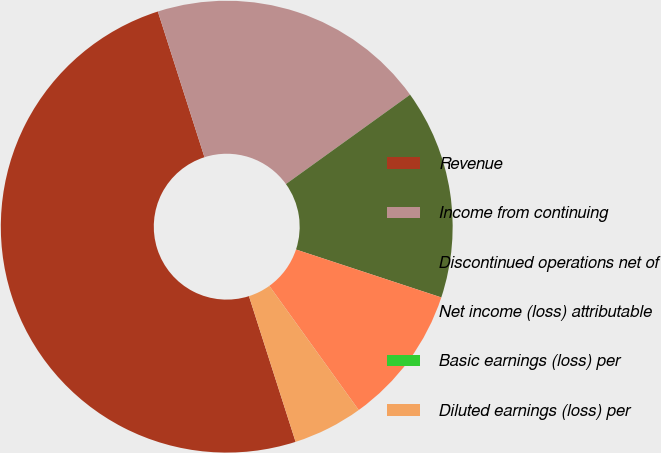Convert chart to OTSL. <chart><loc_0><loc_0><loc_500><loc_500><pie_chart><fcel>Revenue<fcel>Income from continuing<fcel>Discontinued operations net of<fcel>Net income (loss) attributable<fcel>Basic earnings (loss) per<fcel>Diluted earnings (loss) per<nl><fcel>50.0%<fcel>20.0%<fcel>15.0%<fcel>10.0%<fcel>0.0%<fcel>5.0%<nl></chart> 